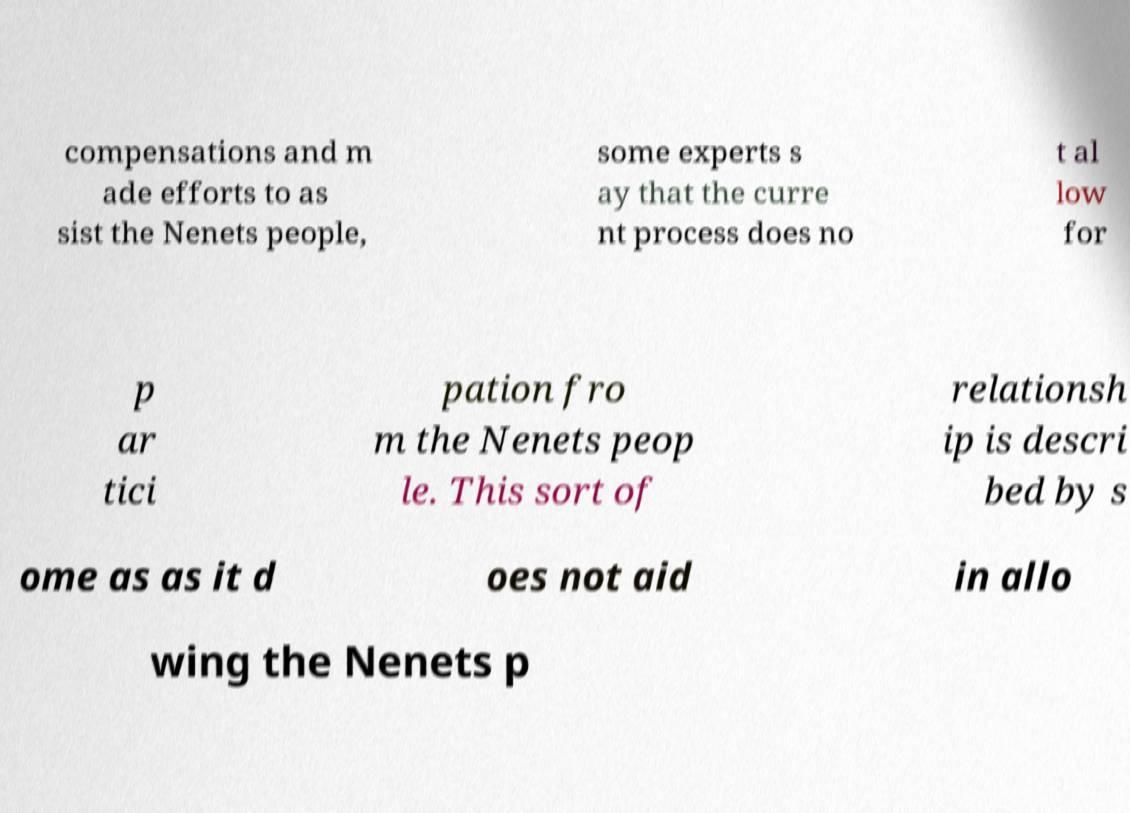There's text embedded in this image that I need extracted. Can you transcribe it verbatim? compensations and m ade efforts to as sist the Nenets people, some experts s ay that the curre nt process does no t al low for p ar tici pation fro m the Nenets peop le. This sort of relationsh ip is descri bed by s ome as as it d oes not aid in allo wing the Nenets p 